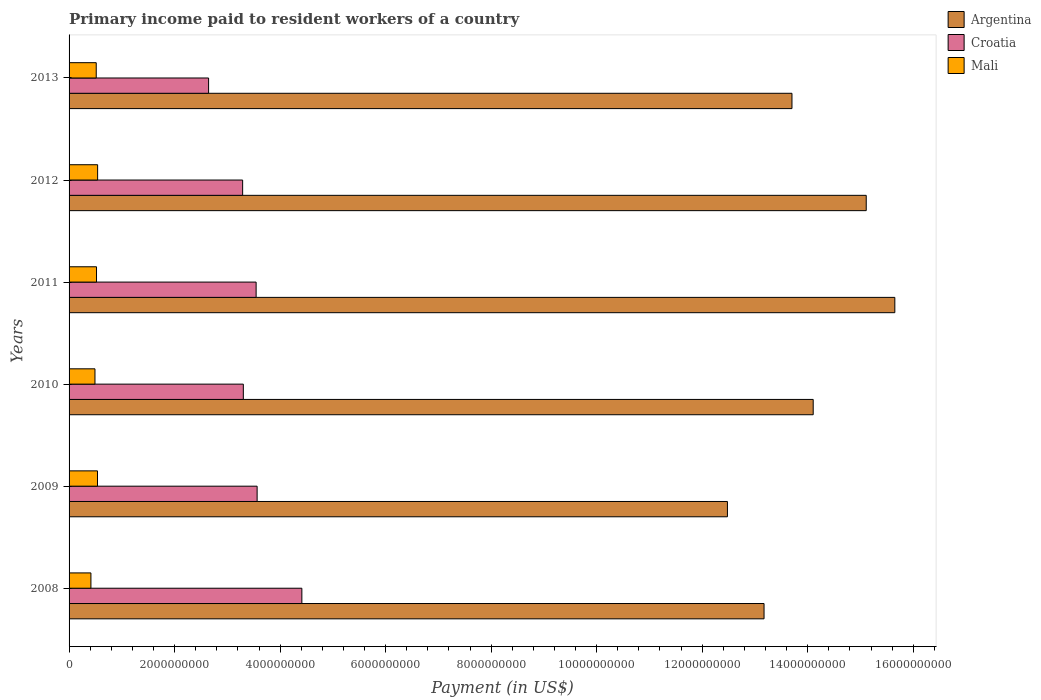How many different coloured bars are there?
Ensure brevity in your answer.  3. How many groups of bars are there?
Your response must be concise. 6. How many bars are there on the 1st tick from the top?
Provide a short and direct response. 3. How many bars are there on the 1st tick from the bottom?
Provide a succinct answer. 3. What is the label of the 3rd group of bars from the top?
Make the answer very short. 2011. In how many cases, is the number of bars for a given year not equal to the number of legend labels?
Make the answer very short. 0. What is the amount paid to workers in Croatia in 2008?
Ensure brevity in your answer.  4.41e+09. Across all years, what is the maximum amount paid to workers in Argentina?
Give a very brief answer. 1.57e+1. Across all years, what is the minimum amount paid to workers in Argentina?
Offer a terse response. 1.25e+1. What is the total amount paid to workers in Croatia in the graph?
Provide a succinct answer. 2.08e+1. What is the difference between the amount paid to workers in Croatia in 2008 and that in 2009?
Offer a very short reply. 8.48e+08. What is the difference between the amount paid to workers in Mali in 2008 and the amount paid to workers in Croatia in 2012?
Ensure brevity in your answer.  -2.88e+09. What is the average amount paid to workers in Mali per year?
Make the answer very short. 5.03e+08. In the year 2008, what is the difference between the amount paid to workers in Croatia and amount paid to workers in Argentina?
Offer a terse response. -8.76e+09. What is the ratio of the amount paid to workers in Croatia in 2009 to that in 2012?
Your answer should be compact. 1.08. Is the amount paid to workers in Croatia in 2009 less than that in 2011?
Offer a very short reply. No. Is the difference between the amount paid to workers in Croatia in 2009 and 2011 greater than the difference between the amount paid to workers in Argentina in 2009 and 2011?
Offer a terse response. Yes. What is the difference between the highest and the second highest amount paid to workers in Mali?
Offer a very short reply. 2.13e+06. What is the difference between the highest and the lowest amount paid to workers in Mali?
Keep it short and to the point. 1.27e+08. What does the 2nd bar from the top in 2011 represents?
Your answer should be compact. Croatia. What does the 2nd bar from the bottom in 2010 represents?
Provide a short and direct response. Croatia. How many bars are there?
Keep it short and to the point. 18. Are all the bars in the graph horizontal?
Your answer should be compact. Yes. How many years are there in the graph?
Make the answer very short. 6. Does the graph contain any zero values?
Ensure brevity in your answer.  No. Where does the legend appear in the graph?
Keep it short and to the point. Top right. What is the title of the graph?
Keep it short and to the point. Primary income paid to resident workers of a country. What is the label or title of the X-axis?
Your response must be concise. Payment (in US$). What is the label or title of the Y-axis?
Your answer should be compact. Years. What is the Payment (in US$) in Argentina in 2008?
Provide a succinct answer. 1.32e+1. What is the Payment (in US$) of Croatia in 2008?
Your answer should be compact. 4.41e+09. What is the Payment (in US$) in Mali in 2008?
Provide a succinct answer. 4.14e+08. What is the Payment (in US$) of Argentina in 2009?
Your response must be concise. 1.25e+1. What is the Payment (in US$) in Croatia in 2009?
Ensure brevity in your answer.  3.56e+09. What is the Payment (in US$) in Mali in 2009?
Provide a short and direct response. 5.39e+08. What is the Payment (in US$) of Argentina in 2010?
Provide a succinct answer. 1.41e+1. What is the Payment (in US$) in Croatia in 2010?
Make the answer very short. 3.30e+09. What is the Payment (in US$) of Mali in 2010?
Offer a very short reply. 4.91e+08. What is the Payment (in US$) in Argentina in 2011?
Offer a very short reply. 1.57e+1. What is the Payment (in US$) in Croatia in 2011?
Your answer should be compact. 3.55e+09. What is the Payment (in US$) of Mali in 2011?
Give a very brief answer. 5.20e+08. What is the Payment (in US$) of Argentina in 2012?
Give a very brief answer. 1.51e+1. What is the Payment (in US$) of Croatia in 2012?
Offer a terse response. 3.29e+09. What is the Payment (in US$) of Mali in 2012?
Your response must be concise. 5.41e+08. What is the Payment (in US$) in Argentina in 2013?
Your answer should be very brief. 1.37e+1. What is the Payment (in US$) in Croatia in 2013?
Keep it short and to the point. 2.64e+09. What is the Payment (in US$) in Mali in 2013?
Offer a very short reply. 5.15e+08. Across all years, what is the maximum Payment (in US$) of Argentina?
Your answer should be compact. 1.57e+1. Across all years, what is the maximum Payment (in US$) in Croatia?
Offer a very short reply. 4.41e+09. Across all years, what is the maximum Payment (in US$) in Mali?
Your answer should be compact. 5.41e+08. Across all years, what is the minimum Payment (in US$) of Argentina?
Offer a terse response. 1.25e+1. Across all years, what is the minimum Payment (in US$) in Croatia?
Give a very brief answer. 2.64e+09. Across all years, what is the minimum Payment (in US$) of Mali?
Offer a terse response. 4.14e+08. What is the total Payment (in US$) in Argentina in the graph?
Give a very brief answer. 8.42e+1. What is the total Payment (in US$) of Croatia in the graph?
Make the answer very short. 2.08e+1. What is the total Payment (in US$) of Mali in the graph?
Make the answer very short. 3.02e+09. What is the difference between the Payment (in US$) of Argentina in 2008 and that in 2009?
Offer a very short reply. 6.94e+08. What is the difference between the Payment (in US$) in Croatia in 2008 and that in 2009?
Offer a very short reply. 8.48e+08. What is the difference between the Payment (in US$) of Mali in 2008 and that in 2009?
Your answer should be compact. -1.25e+08. What is the difference between the Payment (in US$) in Argentina in 2008 and that in 2010?
Your answer should be compact. -9.32e+08. What is the difference between the Payment (in US$) in Croatia in 2008 and that in 2010?
Make the answer very short. 1.11e+09. What is the difference between the Payment (in US$) of Mali in 2008 and that in 2010?
Offer a terse response. -7.65e+07. What is the difference between the Payment (in US$) in Argentina in 2008 and that in 2011?
Offer a terse response. -2.48e+09. What is the difference between the Payment (in US$) of Croatia in 2008 and that in 2011?
Give a very brief answer. 8.67e+08. What is the difference between the Payment (in US$) of Mali in 2008 and that in 2011?
Keep it short and to the point. -1.06e+08. What is the difference between the Payment (in US$) in Argentina in 2008 and that in 2012?
Your answer should be compact. -1.94e+09. What is the difference between the Payment (in US$) in Croatia in 2008 and that in 2012?
Offer a terse response. 1.12e+09. What is the difference between the Payment (in US$) in Mali in 2008 and that in 2012?
Make the answer very short. -1.27e+08. What is the difference between the Payment (in US$) in Argentina in 2008 and that in 2013?
Make the answer very short. -5.29e+08. What is the difference between the Payment (in US$) in Croatia in 2008 and that in 2013?
Provide a short and direct response. 1.77e+09. What is the difference between the Payment (in US$) of Mali in 2008 and that in 2013?
Make the answer very short. -1.00e+08. What is the difference between the Payment (in US$) in Argentina in 2009 and that in 2010?
Ensure brevity in your answer.  -1.63e+09. What is the difference between the Payment (in US$) of Croatia in 2009 and that in 2010?
Provide a short and direct response. 2.61e+08. What is the difference between the Payment (in US$) of Mali in 2009 and that in 2010?
Offer a very short reply. 4.82e+07. What is the difference between the Payment (in US$) of Argentina in 2009 and that in 2011?
Make the answer very short. -3.17e+09. What is the difference between the Payment (in US$) of Croatia in 2009 and that in 2011?
Keep it short and to the point. 1.87e+07. What is the difference between the Payment (in US$) of Mali in 2009 and that in 2011?
Keep it short and to the point. 1.88e+07. What is the difference between the Payment (in US$) of Argentina in 2009 and that in 2012?
Make the answer very short. -2.63e+09. What is the difference between the Payment (in US$) of Croatia in 2009 and that in 2012?
Give a very brief answer. 2.74e+08. What is the difference between the Payment (in US$) of Mali in 2009 and that in 2012?
Your response must be concise. -2.13e+06. What is the difference between the Payment (in US$) in Argentina in 2009 and that in 2013?
Ensure brevity in your answer.  -1.22e+09. What is the difference between the Payment (in US$) of Croatia in 2009 and that in 2013?
Your answer should be very brief. 9.20e+08. What is the difference between the Payment (in US$) of Mali in 2009 and that in 2013?
Ensure brevity in your answer.  2.42e+07. What is the difference between the Payment (in US$) in Argentina in 2010 and that in 2011?
Your answer should be very brief. -1.55e+09. What is the difference between the Payment (in US$) in Croatia in 2010 and that in 2011?
Ensure brevity in your answer.  -2.43e+08. What is the difference between the Payment (in US$) in Mali in 2010 and that in 2011?
Offer a terse response. -2.94e+07. What is the difference between the Payment (in US$) in Argentina in 2010 and that in 2012?
Keep it short and to the point. -1.01e+09. What is the difference between the Payment (in US$) of Croatia in 2010 and that in 2012?
Your answer should be compact. 1.30e+07. What is the difference between the Payment (in US$) of Mali in 2010 and that in 2012?
Offer a terse response. -5.04e+07. What is the difference between the Payment (in US$) of Argentina in 2010 and that in 2013?
Give a very brief answer. 4.02e+08. What is the difference between the Payment (in US$) in Croatia in 2010 and that in 2013?
Make the answer very short. 6.58e+08. What is the difference between the Payment (in US$) of Mali in 2010 and that in 2013?
Offer a terse response. -2.40e+07. What is the difference between the Payment (in US$) of Argentina in 2011 and that in 2012?
Keep it short and to the point. 5.42e+08. What is the difference between the Payment (in US$) in Croatia in 2011 and that in 2012?
Make the answer very short. 2.56e+08. What is the difference between the Payment (in US$) in Mali in 2011 and that in 2012?
Your answer should be very brief. -2.09e+07. What is the difference between the Payment (in US$) of Argentina in 2011 and that in 2013?
Ensure brevity in your answer.  1.95e+09. What is the difference between the Payment (in US$) of Croatia in 2011 and that in 2013?
Offer a terse response. 9.01e+08. What is the difference between the Payment (in US$) in Mali in 2011 and that in 2013?
Provide a succinct answer. 5.42e+06. What is the difference between the Payment (in US$) of Argentina in 2012 and that in 2013?
Keep it short and to the point. 1.41e+09. What is the difference between the Payment (in US$) of Croatia in 2012 and that in 2013?
Your response must be concise. 6.45e+08. What is the difference between the Payment (in US$) in Mali in 2012 and that in 2013?
Provide a short and direct response. 2.63e+07. What is the difference between the Payment (in US$) in Argentina in 2008 and the Payment (in US$) in Croatia in 2009?
Ensure brevity in your answer.  9.61e+09. What is the difference between the Payment (in US$) of Argentina in 2008 and the Payment (in US$) of Mali in 2009?
Your answer should be very brief. 1.26e+1. What is the difference between the Payment (in US$) in Croatia in 2008 and the Payment (in US$) in Mali in 2009?
Provide a succinct answer. 3.87e+09. What is the difference between the Payment (in US$) of Argentina in 2008 and the Payment (in US$) of Croatia in 2010?
Make the answer very short. 9.87e+09. What is the difference between the Payment (in US$) in Argentina in 2008 and the Payment (in US$) in Mali in 2010?
Ensure brevity in your answer.  1.27e+1. What is the difference between the Payment (in US$) of Croatia in 2008 and the Payment (in US$) of Mali in 2010?
Give a very brief answer. 3.92e+09. What is the difference between the Payment (in US$) of Argentina in 2008 and the Payment (in US$) of Croatia in 2011?
Your answer should be very brief. 9.63e+09. What is the difference between the Payment (in US$) of Argentina in 2008 and the Payment (in US$) of Mali in 2011?
Your response must be concise. 1.27e+1. What is the difference between the Payment (in US$) in Croatia in 2008 and the Payment (in US$) in Mali in 2011?
Make the answer very short. 3.89e+09. What is the difference between the Payment (in US$) in Argentina in 2008 and the Payment (in US$) in Croatia in 2012?
Offer a very short reply. 9.88e+09. What is the difference between the Payment (in US$) in Argentina in 2008 and the Payment (in US$) in Mali in 2012?
Your answer should be compact. 1.26e+1. What is the difference between the Payment (in US$) in Croatia in 2008 and the Payment (in US$) in Mali in 2012?
Your answer should be compact. 3.87e+09. What is the difference between the Payment (in US$) of Argentina in 2008 and the Payment (in US$) of Croatia in 2013?
Ensure brevity in your answer.  1.05e+1. What is the difference between the Payment (in US$) of Argentina in 2008 and the Payment (in US$) of Mali in 2013?
Offer a very short reply. 1.27e+1. What is the difference between the Payment (in US$) of Croatia in 2008 and the Payment (in US$) of Mali in 2013?
Provide a short and direct response. 3.90e+09. What is the difference between the Payment (in US$) of Argentina in 2009 and the Payment (in US$) of Croatia in 2010?
Provide a short and direct response. 9.18e+09. What is the difference between the Payment (in US$) of Argentina in 2009 and the Payment (in US$) of Mali in 2010?
Give a very brief answer. 1.20e+1. What is the difference between the Payment (in US$) of Croatia in 2009 and the Payment (in US$) of Mali in 2010?
Provide a succinct answer. 3.07e+09. What is the difference between the Payment (in US$) in Argentina in 2009 and the Payment (in US$) in Croatia in 2011?
Keep it short and to the point. 8.93e+09. What is the difference between the Payment (in US$) of Argentina in 2009 and the Payment (in US$) of Mali in 2011?
Your response must be concise. 1.20e+1. What is the difference between the Payment (in US$) of Croatia in 2009 and the Payment (in US$) of Mali in 2011?
Provide a succinct answer. 3.04e+09. What is the difference between the Payment (in US$) in Argentina in 2009 and the Payment (in US$) in Croatia in 2012?
Ensure brevity in your answer.  9.19e+09. What is the difference between the Payment (in US$) in Argentina in 2009 and the Payment (in US$) in Mali in 2012?
Give a very brief answer. 1.19e+1. What is the difference between the Payment (in US$) of Croatia in 2009 and the Payment (in US$) of Mali in 2012?
Your response must be concise. 3.02e+09. What is the difference between the Payment (in US$) in Argentina in 2009 and the Payment (in US$) in Croatia in 2013?
Ensure brevity in your answer.  9.83e+09. What is the difference between the Payment (in US$) in Argentina in 2009 and the Payment (in US$) in Mali in 2013?
Ensure brevity in your answer.  1.20e+1. What is the difference between the Payment (in US$) in Croatia in 2009 and the Payment (in US$) in Mali in 2013?
Offer a very short reply. 3.05e+09. What is the difference between the Payment (in US$) in Argentina in 2010 and the Payment (in US$) in Croatia in 2011?
Offer a very short reply. 1.06e+1. What is the difference between the Payment (in US$) of Argentina in 2010 and the Payment (in US$) of Mali in 2011?
Your answer should be compact. 1.36e+1. What is the difference between the Payment (in US$) in Croatia in 2010 and the Payment (in US$) in Mali in 2011?
Give a very brief answer. 2.78e+09. What is the difference between the Payment (in US$) in Argentina in 2010 and the Payment (in US$) in Croatia in 2012?
Your answer should be very brief. 1.08e+1. What is the difference between the Payment (in US$) in Argentina in 2010 and the Payment (in US$) in Mali in 2012?
Offer a terse response. 1.36e+1. What is the difference between the Payment (in US$) in Croatia in 2010 and the Payment (in US$) in Mali in 2012?
Offer a terse response. 2.76e+09. What is the difference between the Payment (in US$) of Argentina in 2010 and the Payment (in US$) of Croatia in 2013?
Make the answer very short. 1.15e+1. What is the difference between the Payment (in US$) of Argentina in 2010 and the Payment (in US$) of Mali in 2013?
Keep it short and to the point. 1.36e+1. What is the difference between the Payment (in US$) of Croatia in 2010 and the Payment (in US$) of Mali in 2013?
Provide a succinct answer. 2.79e+09. What is the difference between the Payment (in US$) of Argentina in 2011 and the Payment (in US$) of Croatia in 2012?
Provide a succinct answer. 1.24e+1. What is the difference between the Payment (in US$) of Argentina in 2011 and the Payment (in US$) of Mali in 2012?
Provide a succinct answer. 1.51e+1. What is the difference between the Payment (in US$) in Croatia in 2011 and the Payment (in US$) in Mali in 2012?
Offer a terse response. 3.00e+09. What is the difference between the Payment (in US$) of Argentina in 2011 and the Payment (in US$) of Croatia in 2013?
Your answer should be very brief. 1.30e+1. What is the difference between the Payment (in US$) of Argentina in 2011 and the Payment (in US$) of Mali in 2013?
Keep it short and to the point. 1.51e+1. What is the difference between the Payment (in US$) in Croatia in 2011 and the Payment (in US$) in Mali in 2013?
Ensure brevity in your answer.  3.03e+09. What is the difference between the Payment (in US$) in Argentina in 2012 and the Payment (in US$) in Croatia in 2013?
Ensure brevity in your answer.  1.25e+1. What is the difference between the Payment (in US$) of Argentina in 2012 and the Payment (in US$) of Mali in 2013?
Offer a terse response. 1.46e+1. What is the difference between the Payment (in US$) of Croatia in 2012 and the Payment (in US$) of Mali in 2013?
Keep it short and to the point. 2.78e+09. What is the average Payment (in US$) in Argentina per year?
Provide a short and direct response. 1.40e+1. What is the average Payment (in US$) in Croatia per year?
Your answer should be very brief. 3.46e+09. What is the average Payment (in US$) in Mali per year?
Make the answer very short. 5.03e+08. In the year 2008, what is the difference between the Payment (in US$) in Argentina and Payment (in US$) in Croatia?
Make the answer very short. 8.76e+09. In the year 2008, what is the difference between the Payment (in US$) in Argentina and Payment (in US$) in Mali?
Offer a terse response. 1.28e+1. In the year 2008, what is the difference between the Payment (in US$) in Croatia and Payment (in US$) in Mali?
Provide a succinct answer. 4.00e+09. In the year 2009, what is the difference between the Payment (in US$) of Argentina and Payment (in US$) of Croatia?
Your response must be concise. 8.91e+09. In the year 2009, what is the difference between the Payment (in US$) of Argentina and Payment (in US$) of Mali?
Make the answer very short. 1.19e+1. In the year 2009, what is the difference between the Payment (in US$) of Croatia and Payment (in US$) of Mali?
Make the answer very short. 3.03e+09. In the year 2010, what is the difference between the Payment (in US$) of Argentina and Payment (in US$) of Croatia?
Provide a short and direct response. 1.08e+1. In the year 2010, what is the difference between the Payment (in US$) in Argentina and Payment (in US$) in Mali?
Offer a very short reply. 1.36e+1. In the year 2010, what is the difference between the Payment (in US$) in Croatia and Payment (in US$) in Mali?
Offer a very short reply. 2.81e+09. In the year 2011, what is the difference between the Payment (in US$) in Argentina and Payment (in US$) in Croatia?
Provide a succinct answer. 1.21e+1. In the year 2011, what is the difference between the Payment (in US$) in Argentina and Payment (in US$) in Mali?
Your answer should be very brief. 1.51e+1. In the year 2011, what is the difference between the Payment (in US$) of Croatia and Payment (in US$) of Mali?
Give a very brief answer. 3.03e+09. In the year 2012, what is the difference between the Payment (in US$) of Argentina and Payment (in US$) of Croatia?
Your response must be concise. 1.18e+1. In the year 2012, what is the difference between the Payment (in US$) in Argentina and Payment (in US$) in Mali?
Your answer should be very brief. 1.46e+1. In the year 2012, what is the difference between the Payment (in US$) of Croatia and Payment (in US$) of Mali?
Offer a terse response. 2.75e+09. In the year 2013, what is the difference between the Payment (in US$) in Argentina and Payment (in US$) in Croatia?
Offer a terse response. 1.11e+1. In the year 2013, what is the difference between the Payment (in US$) in Argentina and Payment (in US$) in Mali?
Ensure brevity in your answer.  1.32e+1. In the year 2013, what is the difference between the Payment (in US$) in Croatia and Payment (in US$) in Mali?
Give a very brief answer. 2.13e+09. What is the ratio of the Payment (in US$) in Argentina in 2008 to that in 2009?
Your answer should be very brief. 1.06. What is the ratio of the Payment (in US$) in Croatia in 2008 to that in 2009?
Provide a short and direct response. 1.24. What is the ratio of the Payment (in US$) in Mali in 2008 to that in 2009?
Provide a short and direct response. 0.77. What is the ratio of the Payment (in US$) in Argentina in 2008 to that in 2010?
Provide a succinct answer. 0.93. What is the ratio of the Payment (in US$) in Croatia in 2008 to that in 2010?
Make the answer very short. 1.34. What is the ratio of the Payment (in US$) of Mali in 2008 to that in 2010?
Provide a succinct answer. 0.84. What is the ratio of the Payment (in US$) of Argentina in 2008 to that in 2011?
Your answer should be compact. 0.84. What is the ratio of the Payment (in US$) of Croatia in 2008 to that in 2011?
Provide a short and direct response. 1.24. What is the ratio of the Payment (in US$) of Mali in 2008 to that in 2011?
Ensure brevity in your answer.  0.8. What is the ratio of the Payment (in US$) of Argentina in 2008 to that in 2012?
Your answer should be compact. 0.87. What is the ratio of the Payment (in US$) of Croatia in 2008 to that in 2012?
Provide a short and direct response. 1.34. What is the ratio of the Payment (in US$) in Mali in 2008 to that in 2012?
Make the answer very short. 0.77. What is the ratio of the Payment (in US$) of Argentina in 2008 to that in 2013?
Offer a terse response. 0.96. What is the ratio of the Payment (in US$) in Croatia in 2008 to that in 2013?
Keep it short and to the point. 1.67. What is the ratio of the Payment (in US$) of Mali in 2008 to that in 2013?
Your answer should be very brief. 0.8. What is the ratio of the Payment (in US$) of Argentina in 2009 to that in 2010?
Your response must be concise. 0.88. What is the ratio of the Payment (in US$) in Croatia in 2009 to that in 2010?
Your answer should be very brief. 1.08. What is the ratio of the Payment (in US$) of Mali in 2009 to that in 2010?
Make the answer very short. 1.1. What is the ratio of the Payment (in US$) of Argentina in 2009 to that in 2011?
Your answer should be compact. 0.8. What is the ratio of the Payment (in US$) in Croatia in 2009 to that in 2011?
Make the answer very short. 1.01. What is the ratio of the Payment (in US$) in Mali in 2009 to that in 2011?
Offer a terse response. 1.04. What is the ratio of the Payment (in US$) in Argentina in 2009 to that in 2012?
Your response must be concise. 0.83. What is the ratio of the Payment (in US$) of Croatia in 2009 to that in 2012?
Provide a succinct answer. 1.08. What is the ratio of the Payment (in US$) of Mali in 2009 to that in 2012?
Keep it short and to the point. 1. What is the ratio of the Payment (in US$) in Argentina in 2009 to that in 2013?
Provide a short and direct response. 0.91. What is the ratio of the Payment (in US$) of Croatia in 2009 to that in 2013?
Offer a terse response. 1.35. What is the ratio of the Payment (in US$) of Mali in 2009 to that in 2013?
Your answer should be very brief. 1.05. What is the ratio of the Payment (in US$) in Argentina in 2010 to that in 2011?
Give a very brief answer. 0.9. What is the ratio of the Payment (in US$) in Croatia in 2010 to that in 2011?
Your answer should be very brief. 0.93. What is the ratio of the Payment (in US$) in Mali in 2010 to that in 2011?
Provide a short and direct response. 0.94. What is the ratio of the Payment (in US$) in Argentina in 2010 to that in 2012?
Your response must be concise. 0.93. What is the ratio of the Payment (in US$) in Mali in 2010 to that in 2012?
Keep it short and to the point. 0.91. What is the ratio of the Payment (in US$) of Argentina in 2010 to that in 2013?
Provide a succinct answer. 1.03. What is the ratio of the Payment (in US$) in Croatia in 2010 to that in 2013?
Your response must be concise. 1.25. What is the ratio of the Payment (in US$) of Mali in 2010 to that in 2013?
Give a very brief answer. 0.95. What is the ratio of the Payment (in US$) in Argentina in 2011 to that in 2012?
Offer a terse response. 1.04. What is the ratio of the Payment (in US$) of Croatia in 2011 to that in 2012?
Your response must be concise. 1.08. What is the ratio of the Payment (in US$) in Mali in 2011 to that in 2012?
Make the answer very short. 0.96. What is the ratio of the Payment (in US$) of Argentina in 2011 to that in 2013?
Keep it short and to the point. 1.14. What is the ratio of the Payment (in US$) in Croatia in 2011 to that in 2013?
Make the answer very short. 1.34. What is the ratio of the Payment (in US$) in Mali in 2011 to that in 2013?
Your response must be concise. 1.01. What is the ratio of the Payment (in US$) in Argentina in 2012 to that in 2013?
Your answer should be very brief. 1.1. What is the ratio of the Payment (in US$) of Croatia in 2012 to that in 2013?
Your answer should be compact. 1.24. What is the ratio of the Payment (in US$) of Mali in 2012 to that in 2013?
Keep it short and to the point. 1.05. What is the difference between the highest and the second highest Payment (in US$) of Argentina?
Your response must be concise. 5.42e+08. What is the difference between the highest and the second highest Payment (in US$) of Croatia?
Your response must be concise. 8.48e+08. What is the difference between the highest and the second highest Payment (in US$) of Mali?
Make the answer very short. 2.13e+06. What is the difference between the highest and the lowest Payment (in US$) in Argentina?
Make the answer very short. 3.17e+09. What is the difference between the highest and the lowest Payment (in US$) of Croatia?
Offer a very short reply. 1.77e+09. What is the difference between the highest and the lowest Payment (in US$) in Mali?
Ensure brevity in your answer.  1.27e+08. 